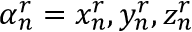<formula> <loc_0><loc_0><loc_500><loc_500>\alpha _ { n } ^ { r } = { x _ { n } ^ { r } , y _ { n } ^ { r } , z _ { n } ^ { r } }</formula> 